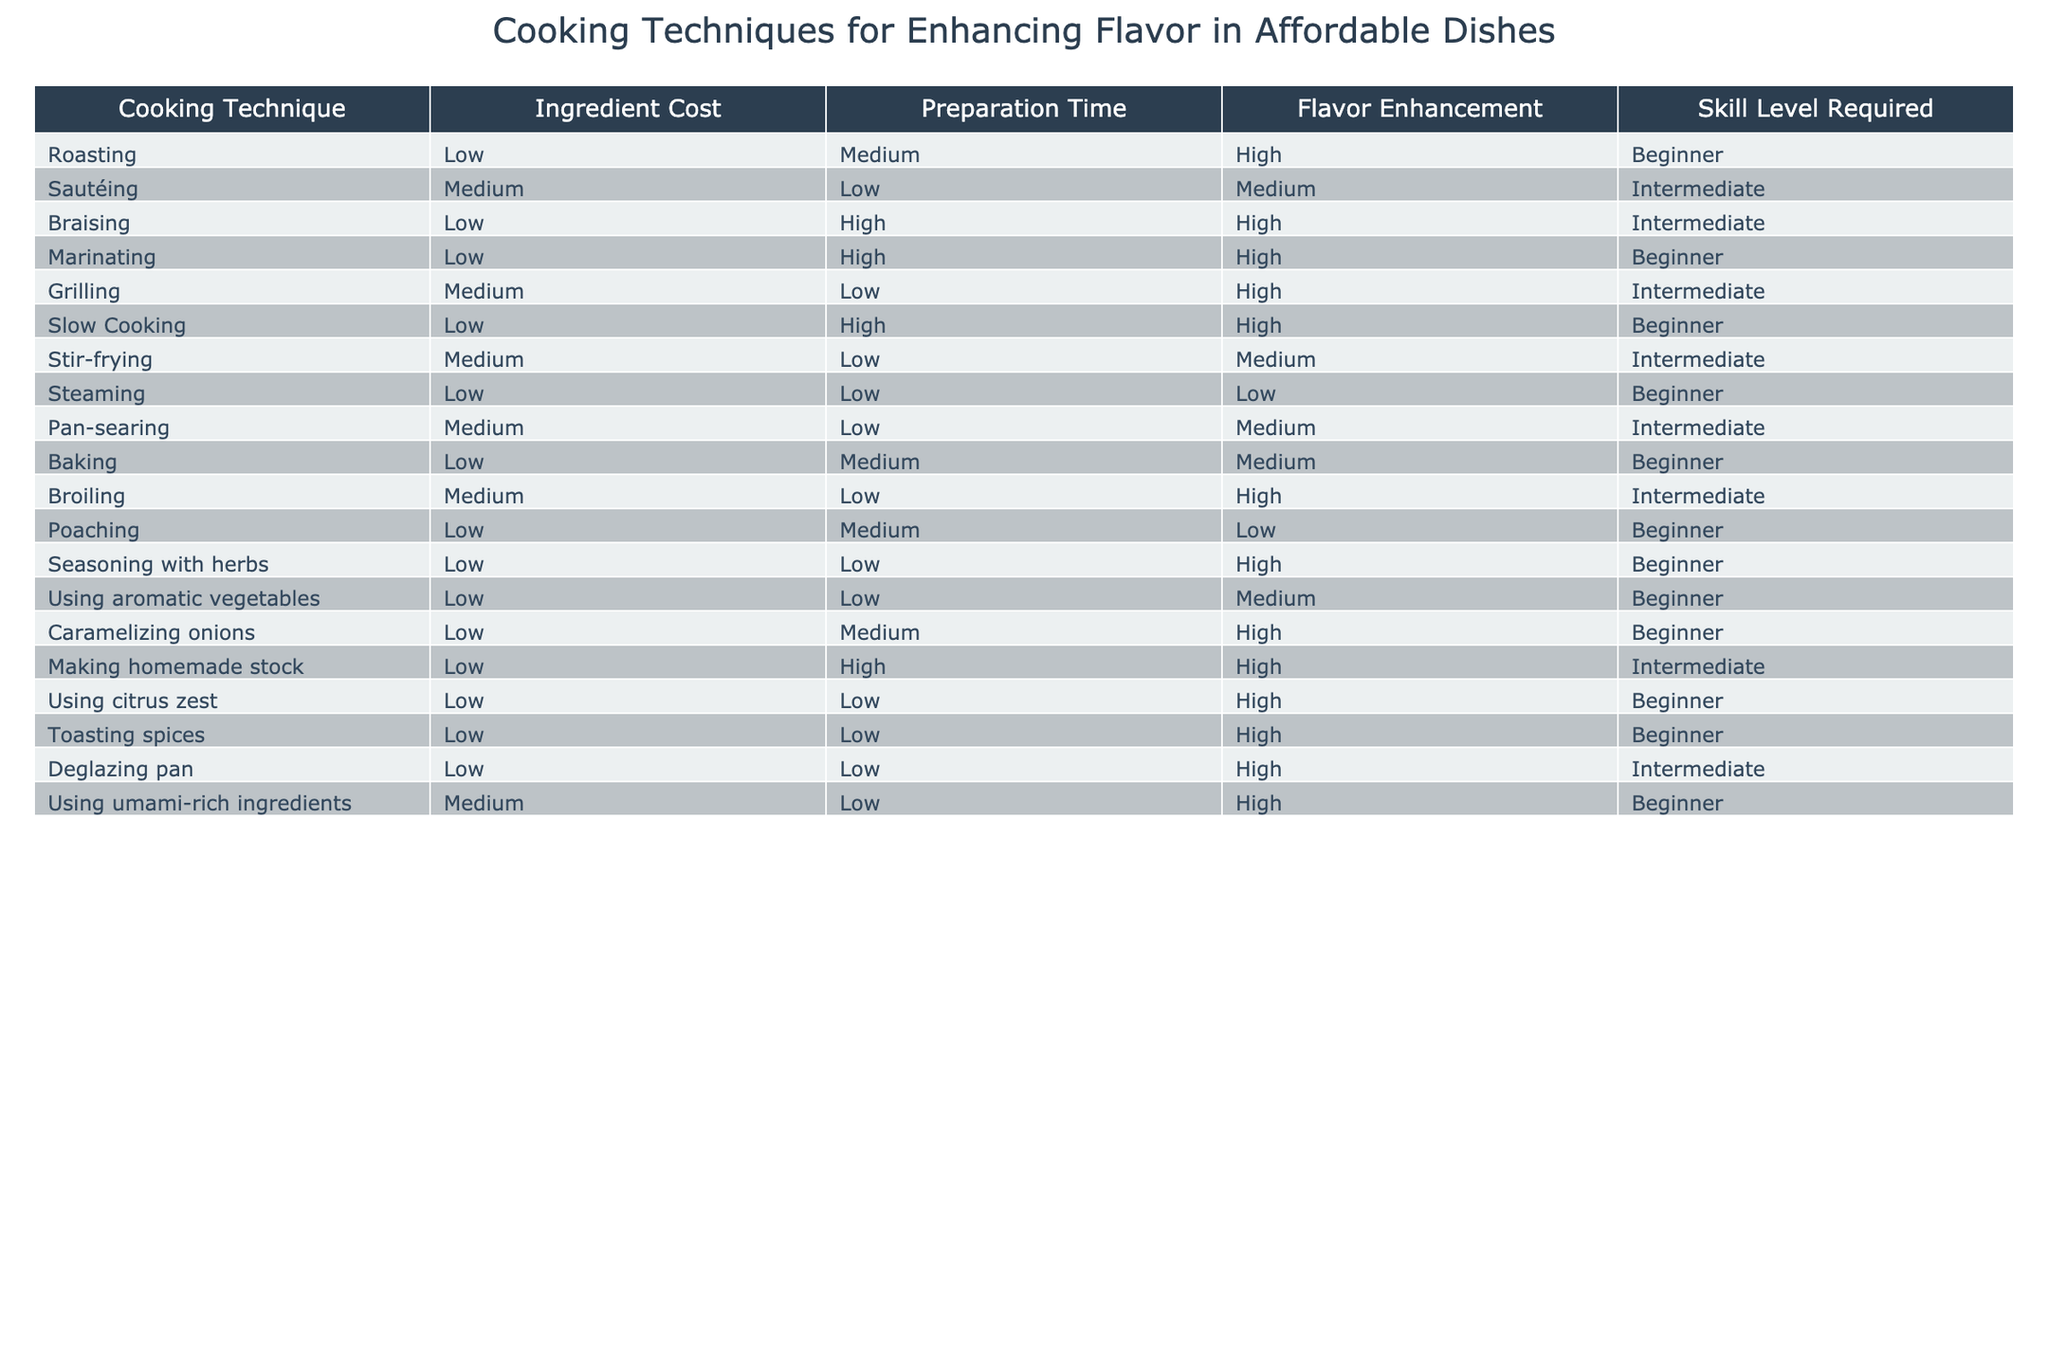What cooking techniques can enhance flavor in a dish that requires low ingredient cost? Looking at the table, the techniques with a low ingredient cost are roasting, braising, marinating, slow cooking, steaming, seasoning with herbs, using aromatic vegetables, caramelizing onions, and making homemade stock.
Answer: Roasting, braising, marinating, slow cooking, steaming, seasoning with herbs, using aromatic vegetables, caramelizing onions, making homemade stock Which techniques require beginner skill levels and high flavor enhancement? From the table, roasting, marinating, slow cooking, seasoning with herbs, using citrus zest, toasting spices, and caramelizing onions are beginner techniques. Among these, roasting, marinating, slow cooking, and caramelizing onions enhance flavor highly.
Answer: Roasting, marinating, slow cooking, caramelizing onions Are there any cooking techniques that have both medium preparation time and medium flavor enhancement? By checking the table, we find that sautéing, pan-searing, and baking all have a medium preparation time and medium flavor enhancement.
Answer: Sautéing, pan-searing, baking What is the difference in preparation time between techniques that enhance flavor highly and those that enhance it low? Techniques enhancing flavor highly like roasting, braising, marinating, slow cooking, grilling, and making homemade stock have medium to high preparation times. Meanwhile, techniques with a low flavor enhancement like steaming and poaching have low to medium preparation times. The average difference can be assessed as high versus low preparation, so we can generally say it’s significant.
Answer: Significant difference How many cooking techniques require an intermediate skill level? The intermediate skill level techniques include sautéing, braising, grilling, stir-frying, pan-searing, broiling, and making homemade stock. Counting these gives a total of seven techniques.
Answer: Seven techniques 